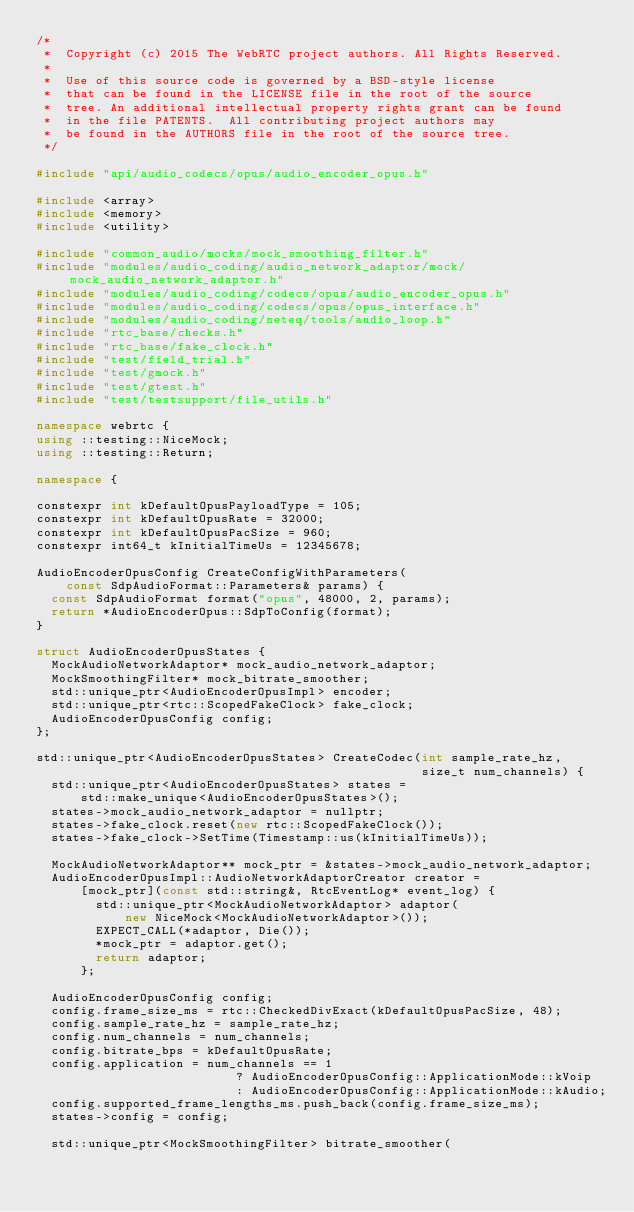<code> <loc_0><loc_0><loc_500><loc_500><_C++_>/*
 *  Copyright (c) 2015 The WebRTC project authors. All Rights Reserved.
 *
 *  Use of this source code is governed by a BSD-style license
 *  that can be found in the LICENSE file in the root of the source
 *  tree. An additional intellectual property rights grant can be found
 *  in the file PATENTS.  All contributing project authors may
 *  be found in the AUTHORS file in the root of the source tree.
 */

#include "api/audio_codecs/opus/audio_encoder_opus.h"

#include <array>
#include <memory>
#include <utility>

#include "common_audio/mocks/mock_smoothing_filter.h"
#include "modules/audio_coding/audio_network_adaptor/mock/mock_audio_network_adaptor.h"
#include "modules/audio_coding/codecs/opus/audio_encoder_opus.h"
#include "modules/audio_coding/codecs/opus/opus_interface.h"
#include "modules/audio_coding/neteq/tools/audio_loop.h"
#include "rtc_base/checks.h"
#include "rtc_base/fake_clock.h"
#include "test/field_trial.h"
#include "test/gmock.h"
#include "test/gtest.h"
#include "test/testsupport/file_utils.h"

namespace webrtc {
using ::testing::NiceMock;
using ::testing::Return;

namespace {

constexpr int kDefaultOpusPayloadType = 105;
constexpr int kDefaultOpusRate = 32000;
constexpr int kDefaultOpusPacSize = 960;
constexpr int64_t kInitialTimeUs = 12345678;

AudioEncoderOpusConfig CreateConfigWithParameters(
    const SdpAudioFormat::Parameters& params) {
  const SdpAudioFormat format("opus", 48000, 2, params);
  return *AudioEncoderOpus::SdpToConfig(format);
}

struct AudioEncoderOpusStates {
  MockAudioNetworkAdaptor* mock_audio_network_adaptor;
  MockSmoothingFilter* mock_bitrate_smoother;
  std::unique_ptr<AudioEncoderOpusImpl> encoder;
  std::unique_ptr<rtc::ScopedFakeClock> fake_clock;
  AudioEncoderOpusConfig config;
};

std::unique_ptr<AudioEncoderOpusStates> CreateCodec(int sample_rate_hz,
                                                    size_t num_channels) {
  std::unique_ptr<AudioEncoderOpusStates> states =
      std::make_unique<AudioEncoderOpusStates>();
  states->mock_audio_network_adaptor = nullptr;
  states->fake_clock.reset(new rtc::ScopedFakeClock());
  states->fake_clock->SetTime(Timestamp::us(kInitialTimeUs));

  MockAudioNetworkAdaptor** mock_ptr = &states->mock_audio_network_adaptor;
  AudioEncoderOpusImpl::AudioNetworkAdaptorCreator creator =
      [mock_ptr](const std::string&, RtcEventLog* event_log) {
        std::unique_ptr<MockAudioNetworkAdaptor> adaptor(
            new NiceMock<MockAudioNetworkAdaptor>());
        EXPECT_CALL(*adaptor, Die());
        *mock_ptr = adaptor.get();
        return adaptor;
      };

  AudioEncoderOpusConfig config;
  config.frame_size_ms = rtc::CheckedDivExact(kDefaultOpusPacSize, 48);
  config.sample_rate_hz = sample_rate_hz;
  config.num_channels = num_channels;
  config.bitrate_bps = kDefaultOpusRate;
  config.application = num_channels == 1
                           ? AudioEncoderOpusConfig::ApplicationMode::kVoip
                           : AudioEncoderOpusConfig::ApplicationMode::kAudio;
  config.supported_frame_lengths_ms.push_back(config.frame_size_ms);
  states->config = config;

  std::unique_ptr<MockSmoothingFilter> bitrate_smoother(</code> 